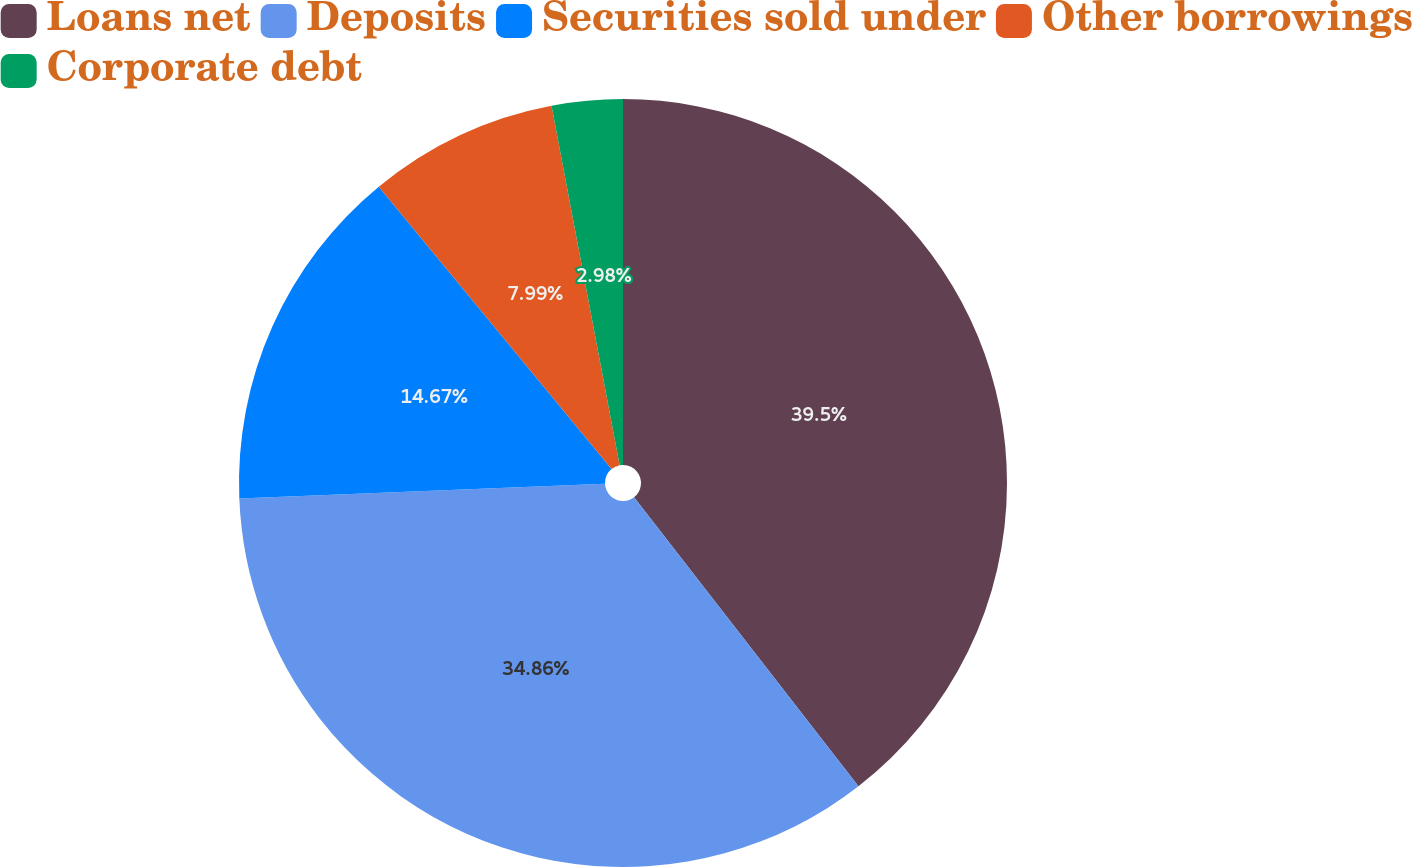<chart> <loc_0><loc_0><loc_500><loc_500><pie_chart><fcel>Loans net<fcel>Deposits<fcel>Securities sold under<fcel>Other borrowings<fcel>Corporate debt<nl><fcel>39.49%<fcel>34.86%<fcel>14.67%<fcel>7.99%<fcel>2.98%<nl></chart> 